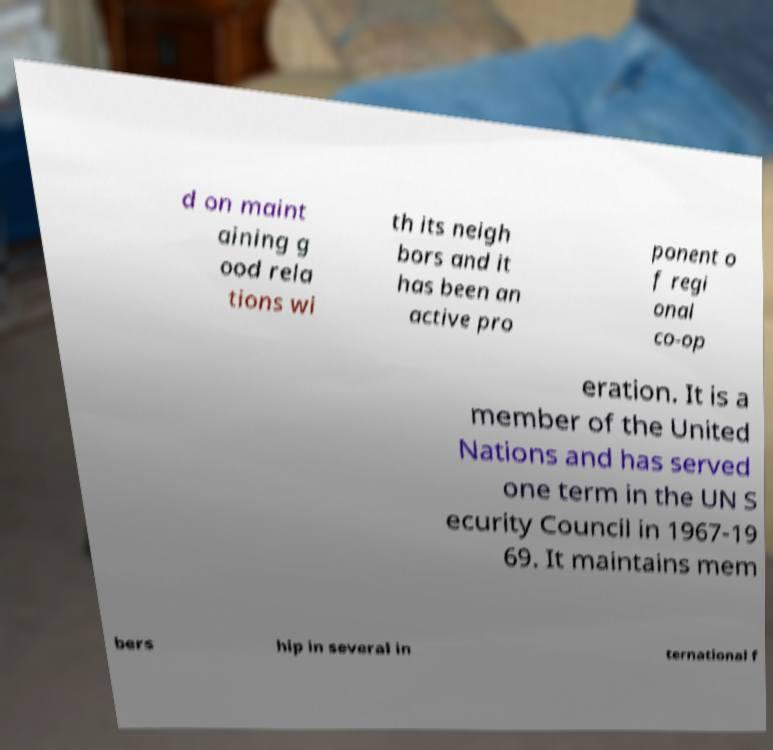Could you assist in decoding the text presented in this image and type it out clearly? d on maint aining g ood rela tions wi th its neigh bors and it has been an active pro ponent o f regi onal co-op eration. It is a member of the United Nations and has served one term in the UN S ecurity Council in 1967-19 69. It maintains mem bers hip in several in ternational f 